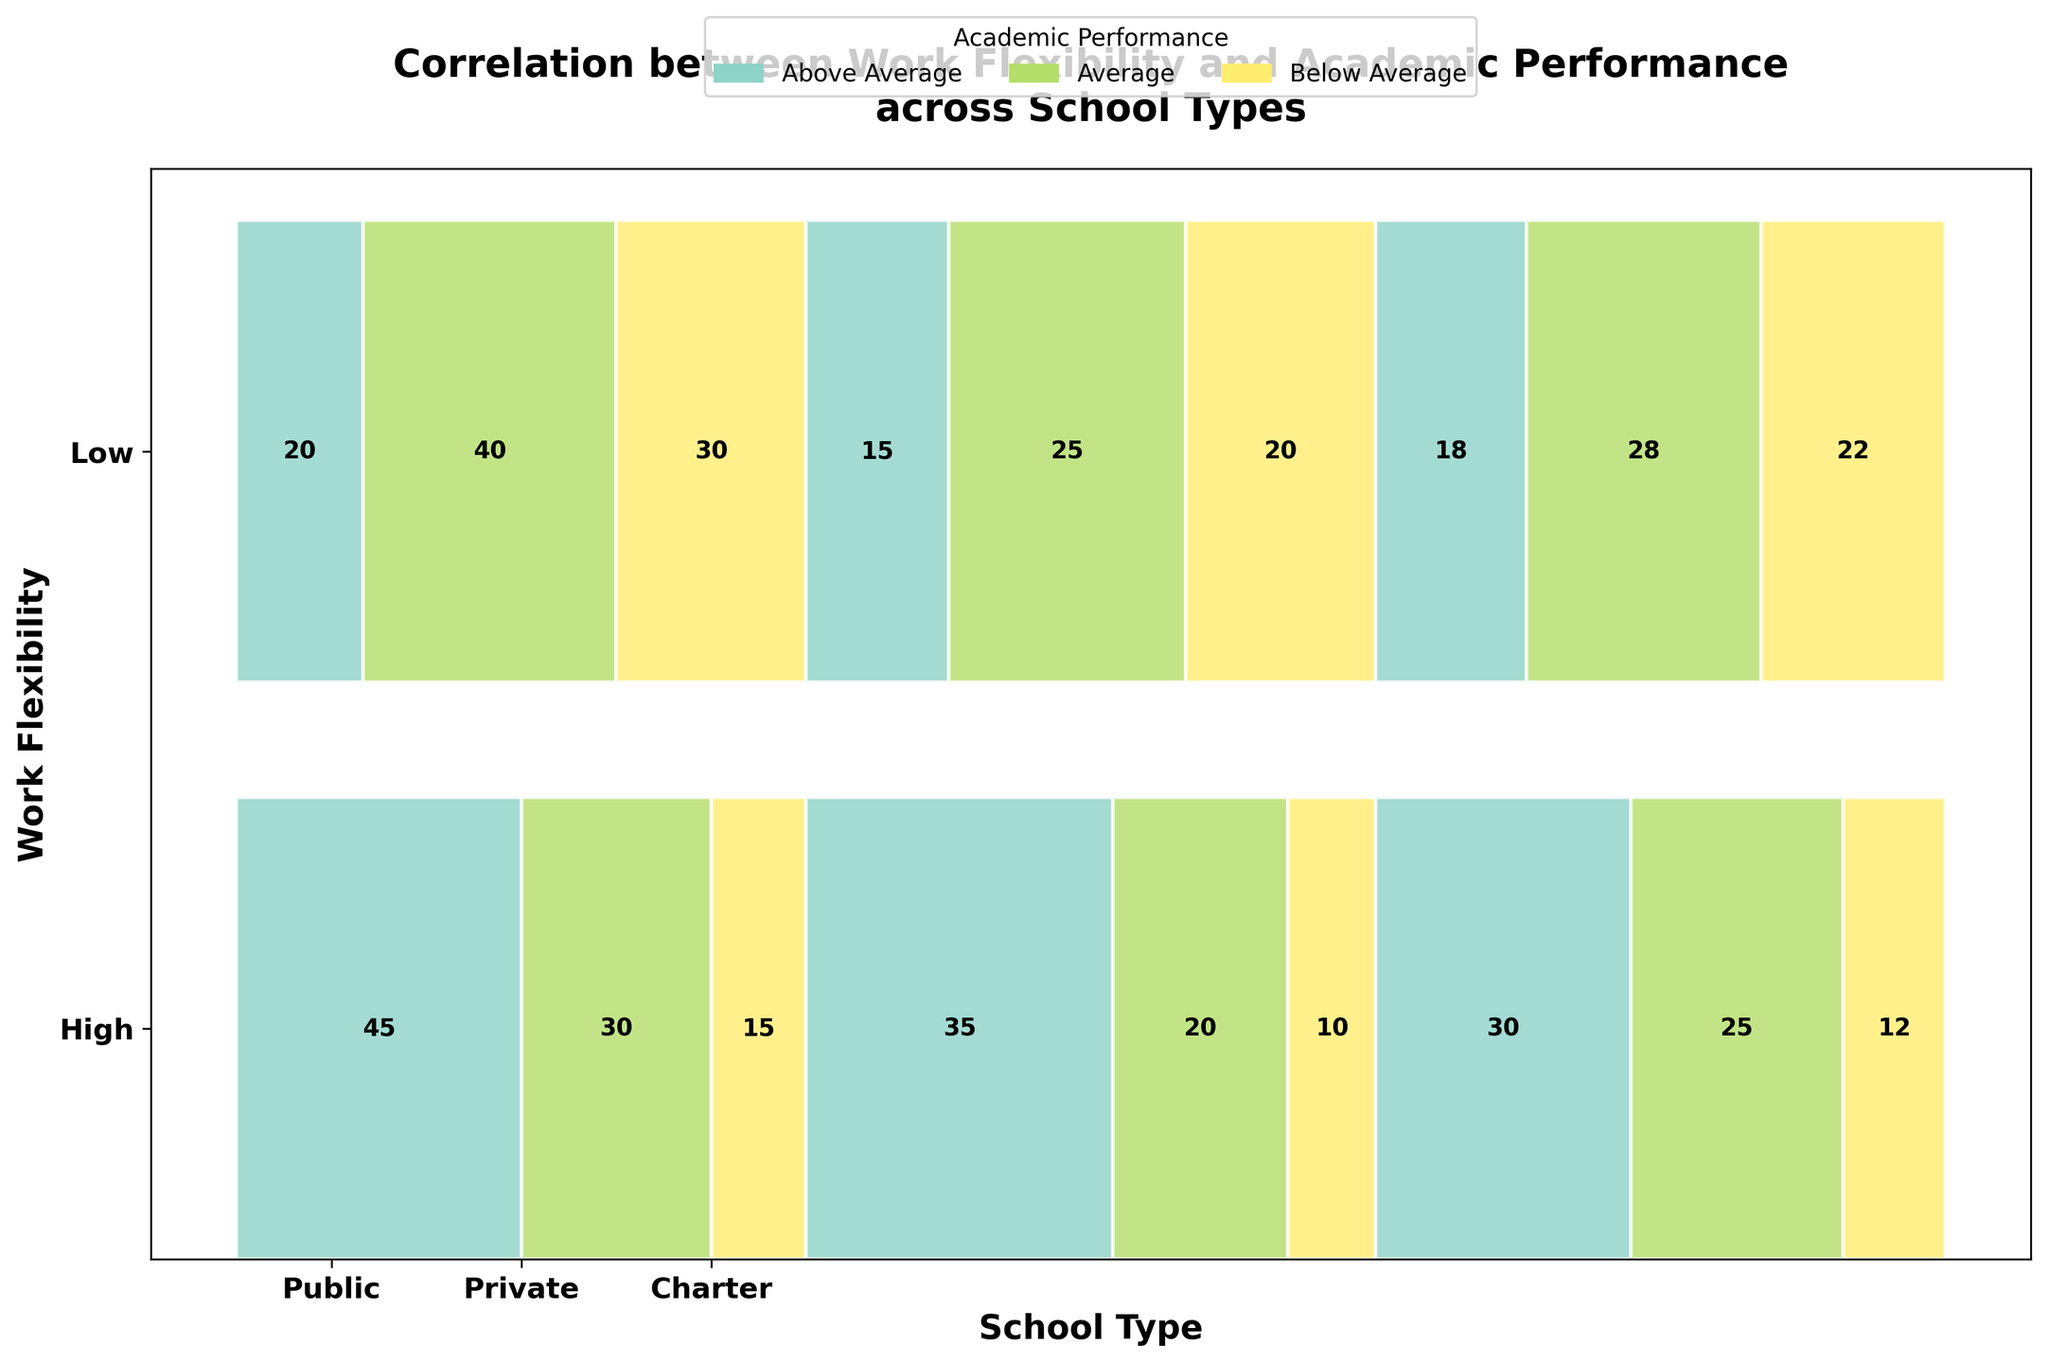What is the title of the figure? The title is usually displayed prominently at the top of the figure to give an overview of what the chart is about. In this case, since the objective is to analyze the correlation between work flexibility and academic performance, the title is specified in the code generating the plot.
Answer: Correlation between Work Flexibility and Academic Performance across School Types What are the performance categories shown in the legend? The legend provides the categories or divisions for the academic performance which are color-coded in the figure. By referring to the color legend, you can see that these categories are usually listed alongside their corresponding colors.
Answer: Above Average, Average, Below Average Which school type shows the highest Above Average academic performance for high work flexibility? To find this, look at the sections labeled "High" for work flexibility and identify which of the school types (Public, Private, Charter) has the longest segment colored for Above Average performance.
Answer: Public How does Below Average academic performance in Public schools compare between high and low work flexibility? Observe the segments representing Below Average performance for Public schools under both high and low work flexibility. Compare their lengths to determine which is greater.
Answer: It's greater in low work flexibility In which school type is the number of students with Average performance similar regardless of their mother's work flexibility? You need to check the segments for Average performance in each school type (Public, Private, Charter) and see where the lengths of these segments are similar between high and low work flexibility.
Answer: Charter Does the Private school type show a stark difference in Above Average performance between high and low work flexibility? Compare the lengths of the segments for Above Average performance in Private schools under high and low work flexibility. Stark differences will be noticeable based on segment size disparities.
Answer: Yes Which academic performance category in Charter schools has the smallest difference between high and low work flexibility? For Charter schools, compare the segment lengths of each academic performance category (Above Average, Average, Below Average) between high and low work flexibility. The category with the least difference in segment lengths will have the smallest difference.
Answer: Above Average What is the total number of students in Public schools with low work flexibility across all performance categories? Add up the counts for Below Average, Average, and Above Average academic performance in Public schools under the low work flexibility category. The values are 30, 40, and 20 respectively.
Answer: 90 Which performance category in Public schools shows less impact of work flexibility, if any? To answer this, compare the segment lengths for Above Average, Average, and Below Average performance in Public schools. Identify which category shows the least change in segment length between high and low work flexibility.
Answer: Average Is the number of below-average students in Charter schools higher when work flexibility is low compared to high? Compare the segment lengths for Below Average performance in Charter schools under high and low work flexibility. A longer segment would indicate a higher count.
Answer: Yes 